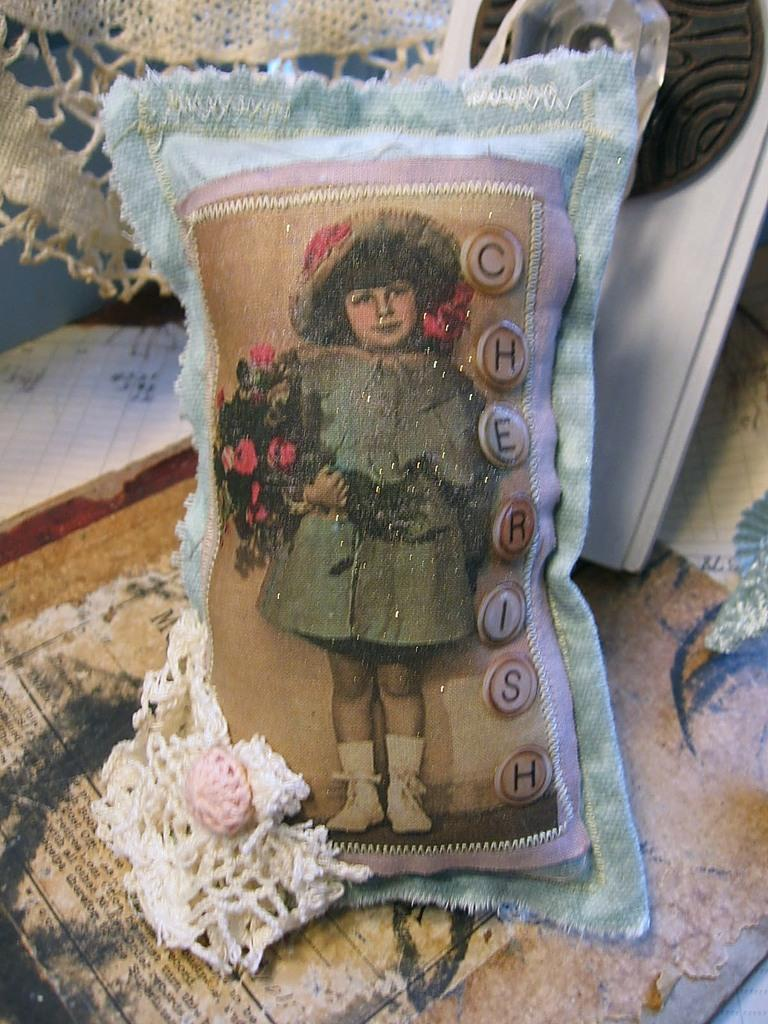What is the main object in the middle of the image? There is a pillow in the middle of the image. What design is on the pillow? The pillow has a design of a girl holding flowers. What is located at the bottom of the image? There is a mat at the bottom of the image. What action is the girl's father taking in the image? There is no father or action present in the image; it only features a pillow with a design of a girl holding flowers and a mat at the bottom. 